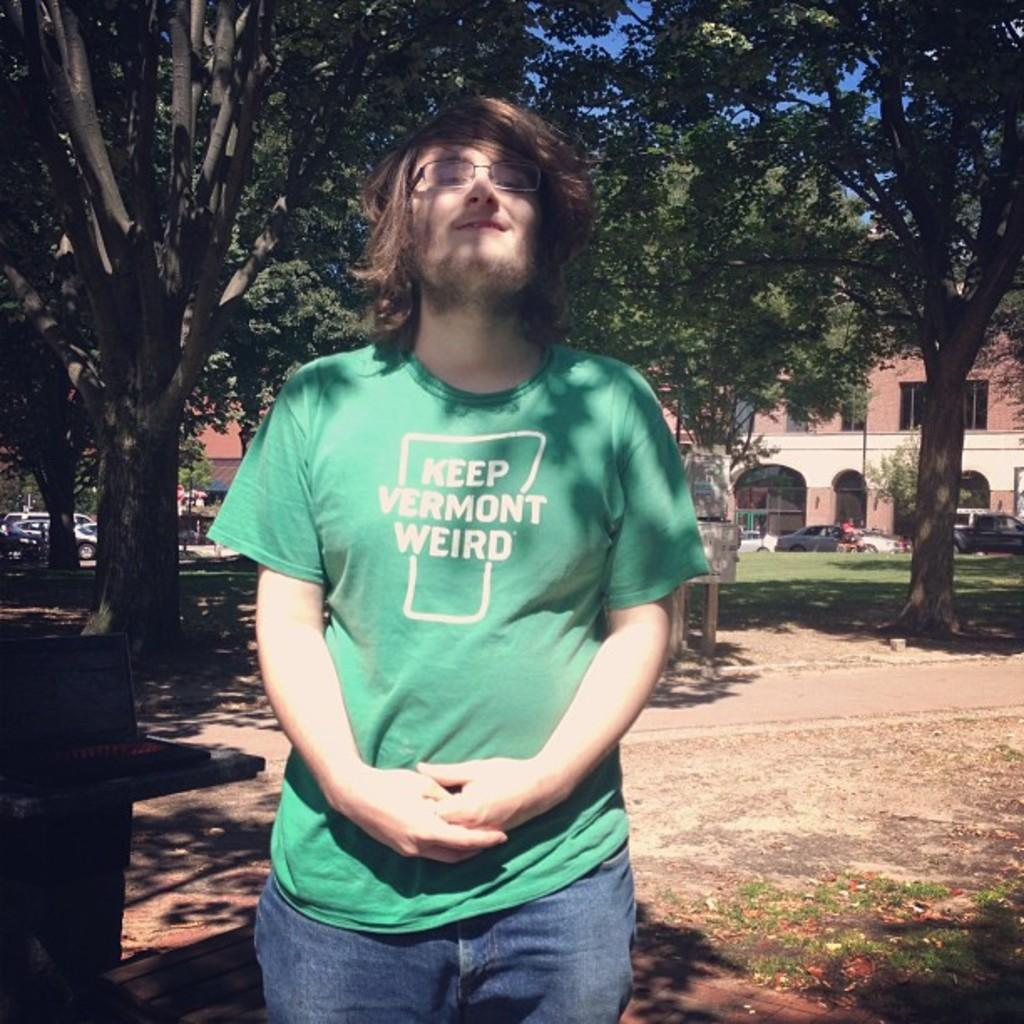What is the main subject of the image? There is a person standing in the front of the image. What is the person's expression in the image? The person is smiling. What can be seen in the background of the image? There are trees, cars, and buildings in the background of the image. What type of vegetation is present in the image? There is grass on the ground in the image. What year is the governor mentioned in the image? There is no mention of a governor or a specific year in the image. What type of root can be seen growing from the person's foot in the image? There is no root growing from the person's foot in the image. 